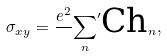<formula> <loc_0><loc_0><loc_500><loc_500>\sigma _ { x y } = \frac { e ^ { 2 } } { } { \sum _ { n } } ^ { \prime } \text {Ch} _ { n } ,</formula> 